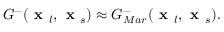Convert formula to latex. <formula><loc_0><loc_0><loc_500><loc_500>G ^ { - } ( x _ { l } , x _ { s } ) \approx G _ { M a r } ^ { - } ( x _ { l } , x _ { s } ) .</formula> 